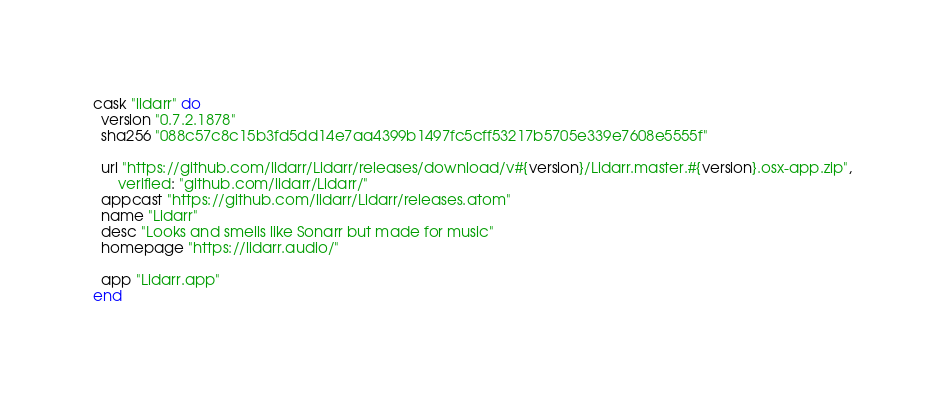Convert code to text. <code><loc_0><loc_0><loc_500><loc_500><_Ruby_>cask "lidarr" do
  version "0.7.2.1878"
  sha256 "088c57c8c15b3fd5dd14e7aa4399b1497fc5cff53217b5705e339e7608e5555f"

  url "https://github.com/lidarr/Lidarr/releases/download/v#{version}/Lidarr.master.#{version}.osx-app.zip",
      verified: "github.com/lidarr/Lidarr/"
  appcast "https://github.com/lidarr/Lidarr/releases.atom"
  name "Lidarr"
  desc "Looks and smells like Sonarr but made for music"
  homepage "https://lidarr.audio/"

  app "Lidarr.app"
end
</code> 